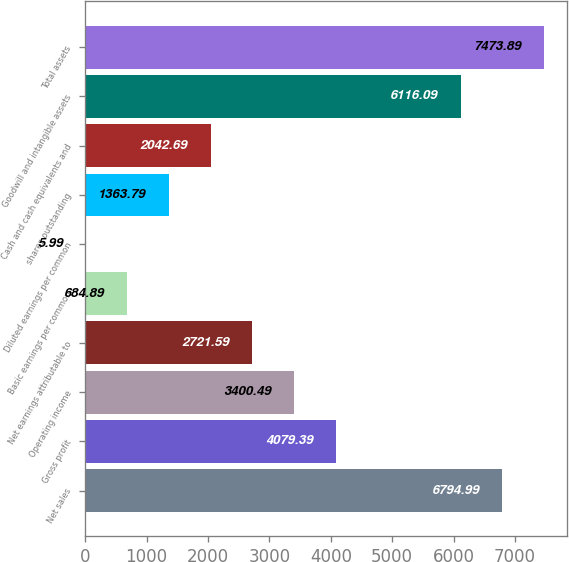Convert chart. <chart><loc_0><loc_0><loc_500><loc_500><bar_chart><fcel>Net sales<fcel>Gross profit<fcel>Operating income<fcel>Net earnings attributable to<fcel>Basic earnings per common<fcel>Diluted earnings per common<fcel>shares outstanding<fcel>Cash and cash equivalents and<fcel>Goodwill and intangible assets<fcel>Total assets<nl><fcel>6794.99<fcel>4079.39<fcel>3400.49<fcel>2721.59<fcel>684.89<fcel>5.99<fcel>1363.79<fcel>2042.69<fcel>6116.09<fcel>7473.89<nl></chart> 